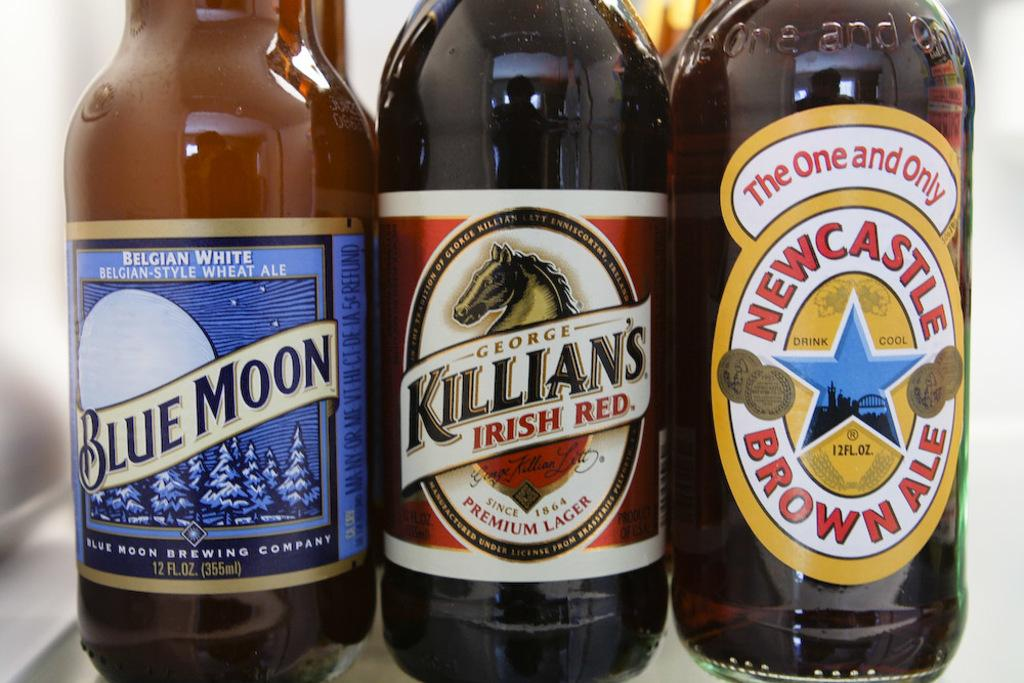<image>
Give a short and clear explanation of the subsequent image. A bottle of Blue Moon Belgian White, Killian's Irish Red, and Newcastle Brown Ale sitting next to each other. 